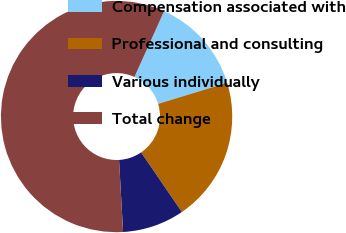Convert chart. <chart><loc_0><loc_0><loc_500><loc_500><pie_chart><fcel>Compensation associated with<fcel>Professional and consulting<fcel>Various individually<fcel>Total change<nl><fcel>13.54%<fcel>20.17%<fcel>8.65%<fcel>57.64%<nl></chart> 